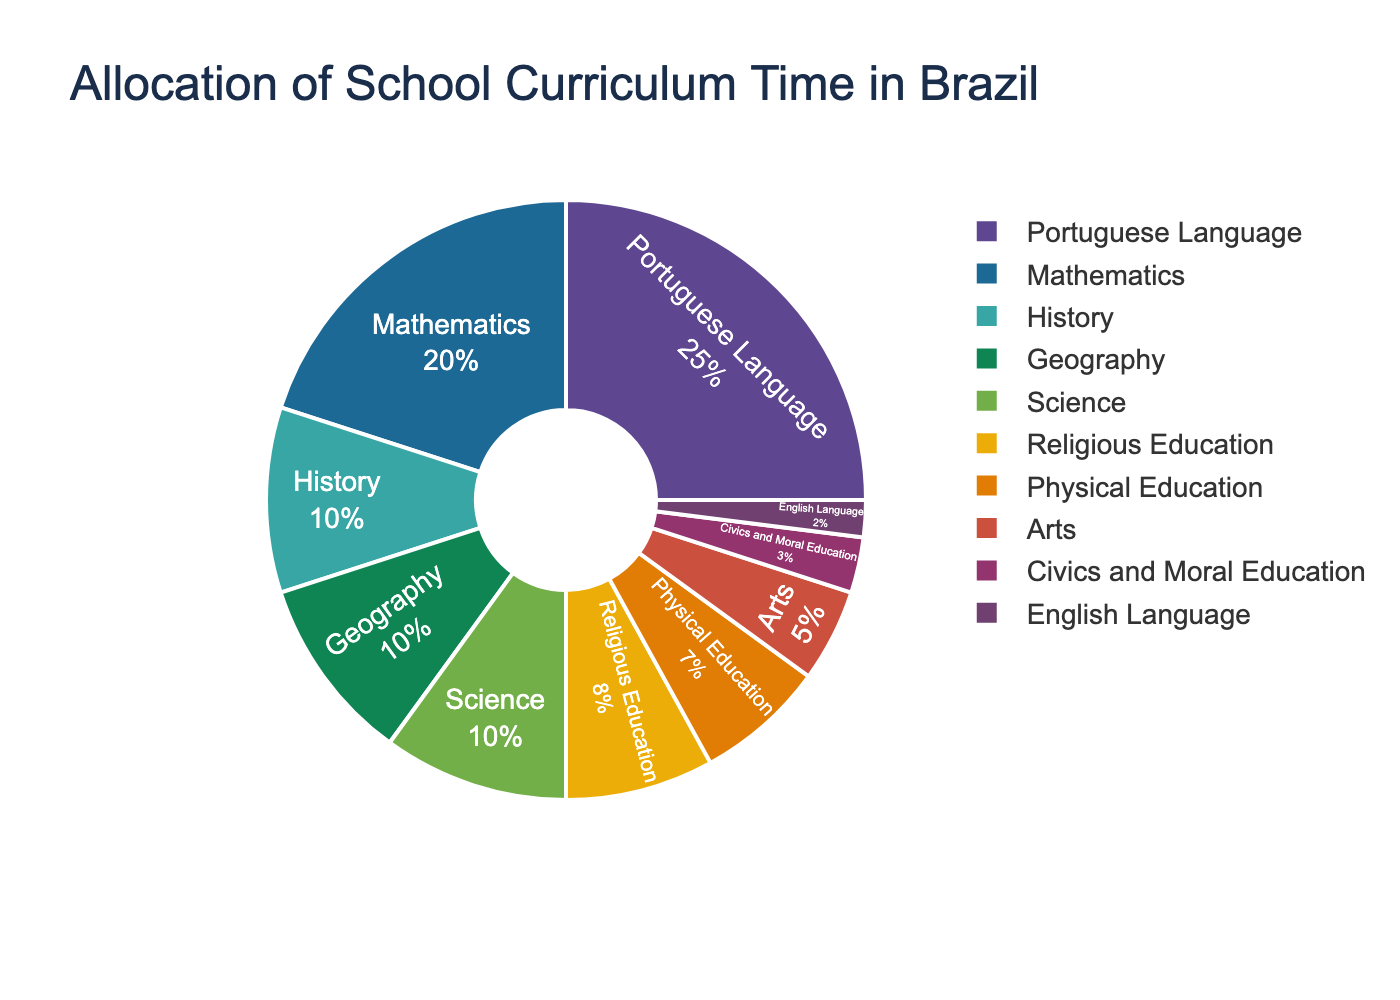What is the most time-consuming subject in the curriculum? The pie chart shows the allocation of school curriculum time where the largest portion is attributed to the Portuguese Language. By comparing the different sections, it is clear that the Portuguese Language takes the highest percentage.
Answer: Portuguese Language What is the total percentage allocated to social science subjects (History, Geography, Civics and Moral Education)? By summing up the percentages of History (10%), Geography (10%), and Civics and Moral Education (3%), the total is 10 + 10 + 3 = 23%.
Answer: 23% Which subject receives less time than Religious Education but more time than English Language? The pie chart shows that Religious Education is allocated 8% and English Language is allocated 2%. The subject that fits in between these two percentages is Physical Education with 7%.
Answer: Physical Education How much more time is allocated to Mathematics compared to Civics and Moral Education? Mathematics is allocated 20% of the curriculum time, whereas Civics and Moral Education receives 3%. The difference is 20 - 3 = 17%.
Answer: 17% Which subjects combined make up one-third of the total curriculum time? The total curriculum time is 100%. One-third of this is approximately 33%. By combining Portuguese Language (25%) and Mathematics (20%), we get 25 + 20 = 45%, which exceeds one-third. Combining Portuguese Language (25%) with History (10%) gives 25 + 10 = 35%, which is also slightly over one-third. Therefore, the closest combination is Portuguese Language (25%) and History (10%) for a total of 35%.
Answer: Portuguese Language and History How does the time allocated to Arts compare to that allocated to Physical Education? The pie chart indicates that Arts is allocated 5% of the curriculum time, while Physical Education is allocated 7%. Therefore, Physical Education receives more time by 7 - 5 = 2%.
Answer: Physical Education gets 2% more What is the combined percentage for subjects related to languages? The subjects related to languages in the chart are Portuguese Language (25%) and English Language (2%). Adding these two up gives 25 + 2 = 27%.
Answer: 27% Which subject has the smallest allocation of curriculum time? By inspecting the pie chart, it can be seen that the smallest section corresponds to the English Language, which is allocated 2%.
Answer: English Language If Arts were to receive 2% more, which subject would it equal in allocation? Currently, Arts is allocated 5%. If it receives 2% more, it would have 5 + 2 = 7%, which is the same percentage allocated to Physical Education.
Answer: Physical Education 